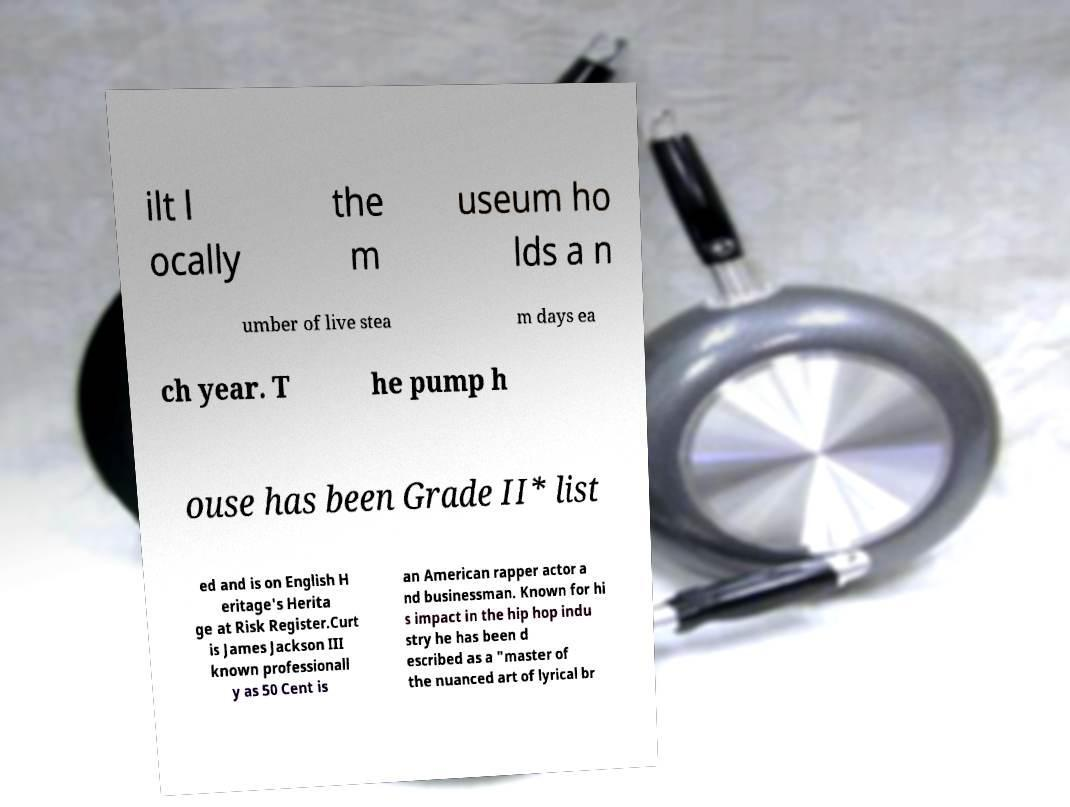Can you read and provide the text displayed in the image?This photo seems to have some interesting text. Can you extract and type it out for me? ilt l ocally the m useum ho lds a n umber of live stea m days ea ch year. T he pump h ouse has been Grade II* list ed and is on English H eritage's Herita ge at Risk Register.Curt is James Jackson III known professionall y as 50 Cent is an American rapper actor a nd businessman. Known for hi s impact in the hip hop indu stry he has been d escribed as a "master of the nuanced art of lyrical br 